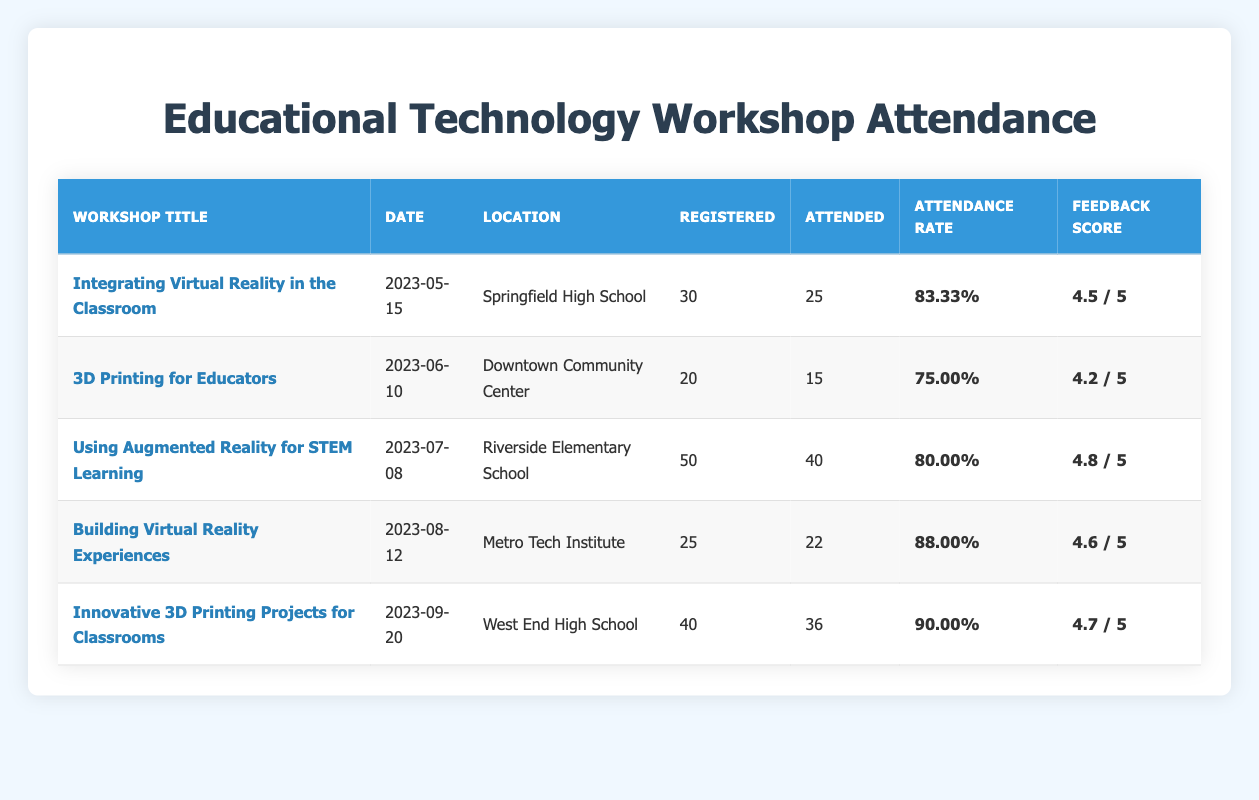What is the attendance rate for the workshop "3D Printing for Educators"? The attendance rate for the workshop "3D Printing for Educators" can be found in the table. It shows that the attendance rate is 75.00.
Answer: 75.00 Which workshop had the highest feedback score? By examining the feedback scores in the table, "Using Augmented Reality for STEM Learning" has the highest score of 4.8.
Answer: 4.8 What was the date of the workshop "Integrating Virtual Reality in the Classroom"? The date for the "Integrating Virtual Reality in the Classroom" workshop is listed in the table as 2023-05-15.
Answer: 2023-05-15 How many total participants registered across all workshops? To find the total registered participants, we sum the registered participants for each workshop: 30 + 20 + 50 + 25 + 40 = 165.
Answer: 165 Was the attendance rate for the workshop "Building Virtual Reality Experiences" above 85 percent? The attendance rate for "Building Virtual Reality Experiences" is 88.00, which is above 85 percent, so the answer is yes.
Answer: Yes What is the average attendance rate for all workshops? To calculate the average attendance rate, we sum all attendance rates: 83.33 + 75.00 + 80.00 + 88.00 + 90.00 = 416.33. Then divide by the number of workshops (5): 416.33 / 5 = 83.27.
Answer: 83.27 Did the workshop "Innovative 3D Printing Projects for Classrooms" have a feedback score below 4.5? The feedback score for "Innovative 3D Printing Projects for Classrooms" is 4.7, which is not below 4.5. Therefore, the answer is no.
Answer: No Which location hosted the workshop with the lowest attendance rate? The attendance rates are compared across workshops, and the lowest rate is 75.00 for "3D Printing for Educators," which was held at Downtown Community Center.
Answer: Downtown Community Center What is the difference in attendance rates between the workshops "Integrating Virtual Reality in the Classroom" and "Innovative 3D Printing Projects for Classrooms"? The attendance rate for "Integrating Virtual Reality in the Classroom" is 83.33 and for "Innovative 3D Printing Projects for Classrooms" is 90.00. The difference is 90.00 - 83.33 = 6.67.
Answer: 6.67 